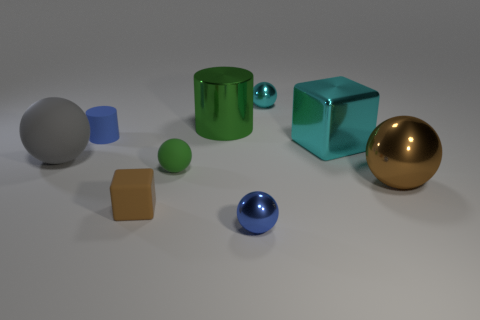How many other things are the same shape as the tiny cyan object?
Keep it short and to the point. 4. How many cyan objects are large matte things or metallic blocks?
Make the answer very short. 1. There is a small cylinder that is the same material as the tiny brown cube; what color is it?
Ensure brevity in your answer.  Blue. Is the cylinder that is behind the blue matte object made of the same material as the cube that is behind the brown matte block?
Make the answer very short. Yes. There is a object that is the same color as the big shiny sphere; what is its size?
Your response must be concise. Small. There is a small sphere that is behind the small green matte ball; what is its material?
Keep it short and to the point. Metal. There is a brown object on the right side of the big green shiny cylinder; is it the same shape as the cyan metal thing on the left side of the cyan metallic block?
Your answer should be compact. Yes. There is a tiny object that is the same color as the big metal ball; what is its material?
Your response must be concise. Rubber. Are there any brown rubber cylinders?
Your answer should be very brief. No. There is a tiny green thing that is the same shape as the blue shiny object; what is it made of?
Make the answer very short. Rubber. 